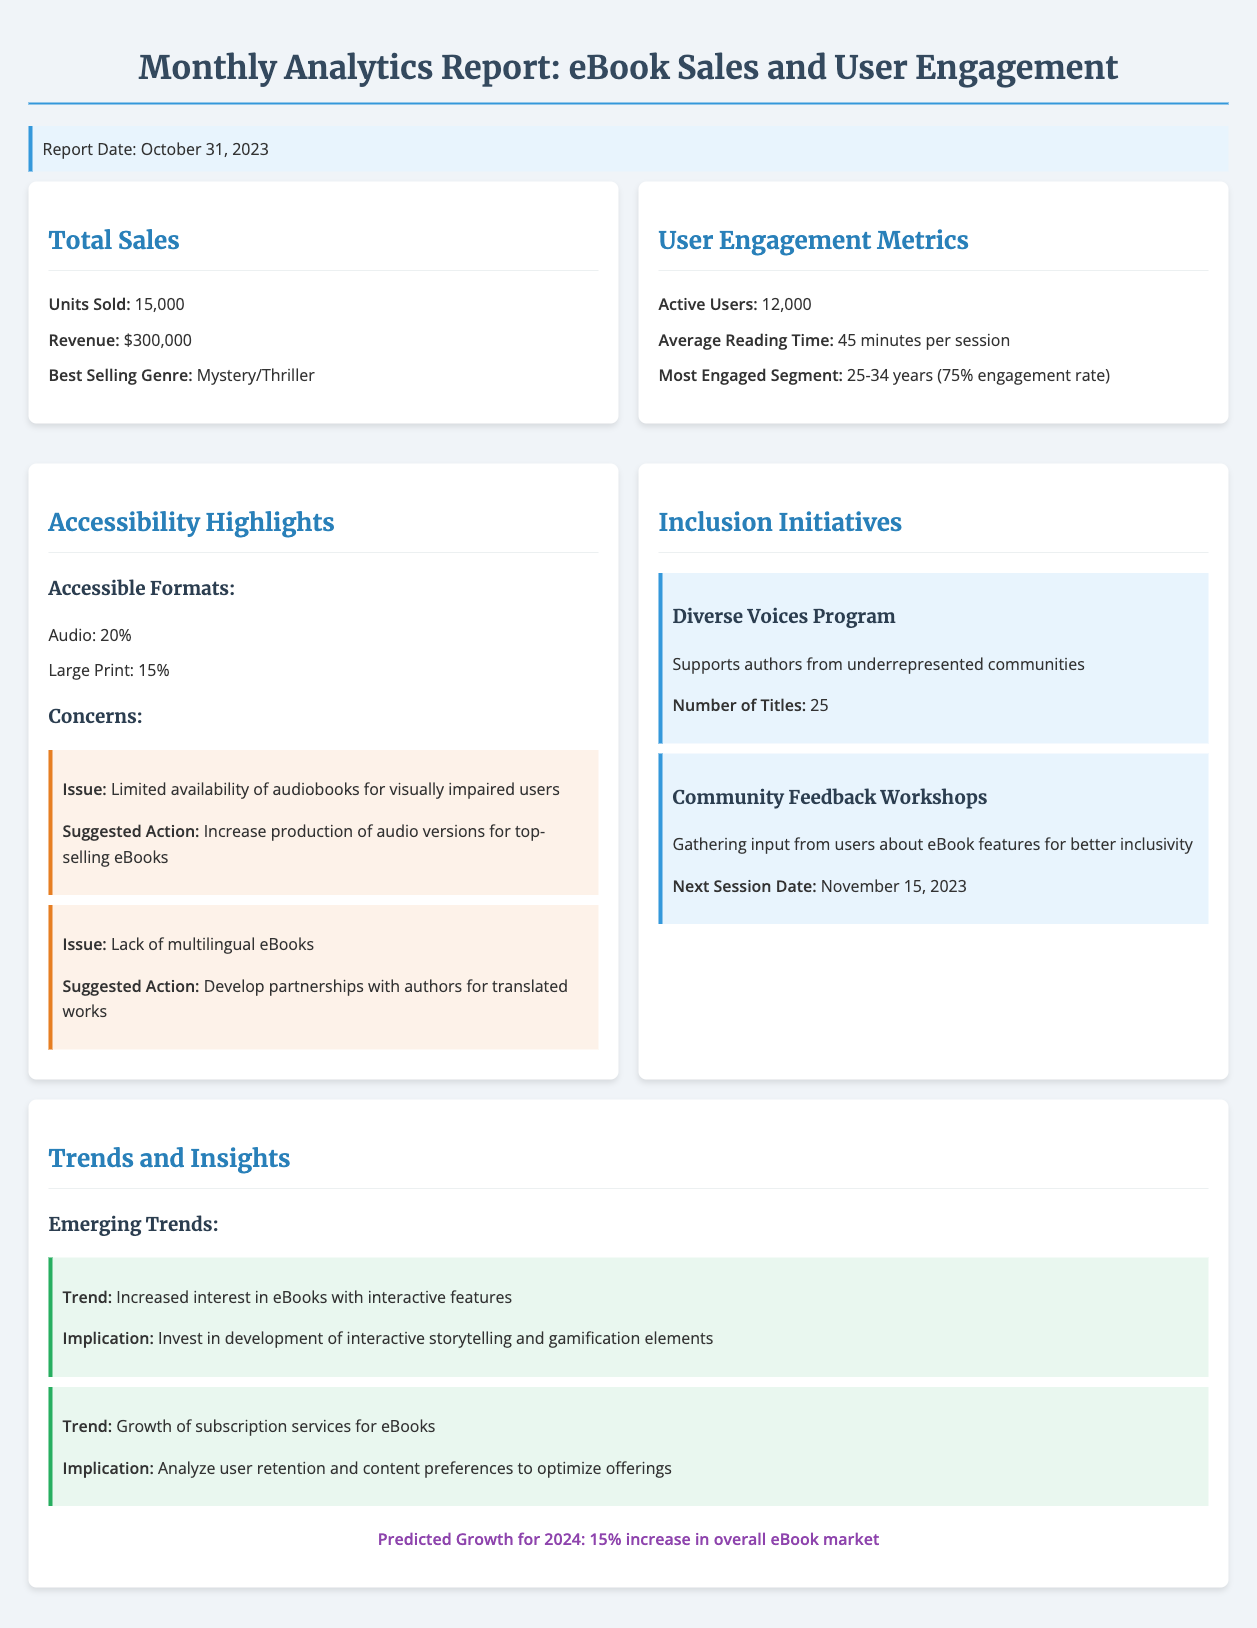What is the total number of units sold? The total number of units sold is mentioned in the total sales section of the document.
Answer: 15,000 What was the revenue generated from eBook sales? The revenue is explicitly stated in the total sales section of the document.
Answer: $300,000 Which genre had the highest sales? The best-selling genre is identified in the total sales section of the report.
Answer: Mystery/Thriller How many active users were recorded? The number of active users is detailed in the user engagement metrics section.
Answer: 12,000 What is the average reading time per session? The average reading time per session is provided in the user engagement metrics section.
Answer: 45 minutes What percentage of eBooks are available in audio format? The percentage of accessible formats is shown in the accessibility highlights section.
Answer: 20% What is one concern regarding accessibility? A specific issue related to accessibility is listed in the accessibility highlights section of the report.
Answer: Limited availability of audiobooks for visually impaired users What initiative supports authors from underrepresented communities? The specific program that supports these authors is noted in the inclusion initiatives section.
Answer: Diverse Voices Program What is the predicted growth for the overall eBook market in 2024? The expected growth rate is mentioned in the trends and insights section of the report.
Answer: 15% increase 